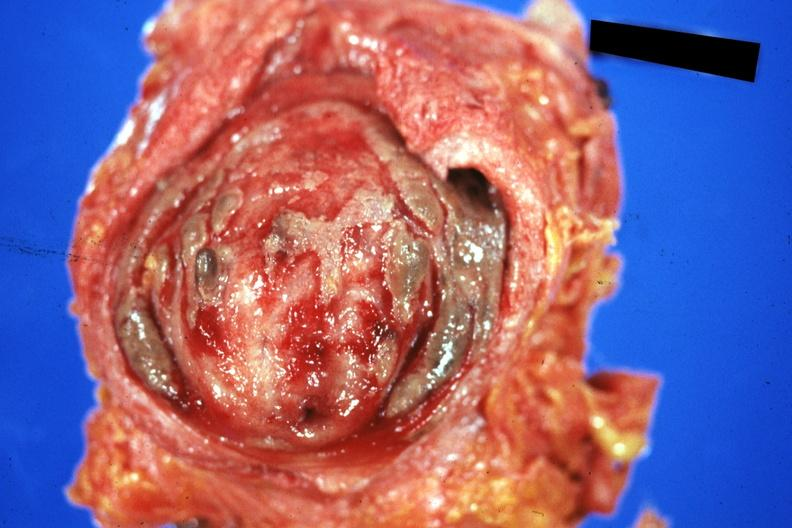what is present?
Answer the question using a single word or phrase. Cystitis ulcerative purulent 